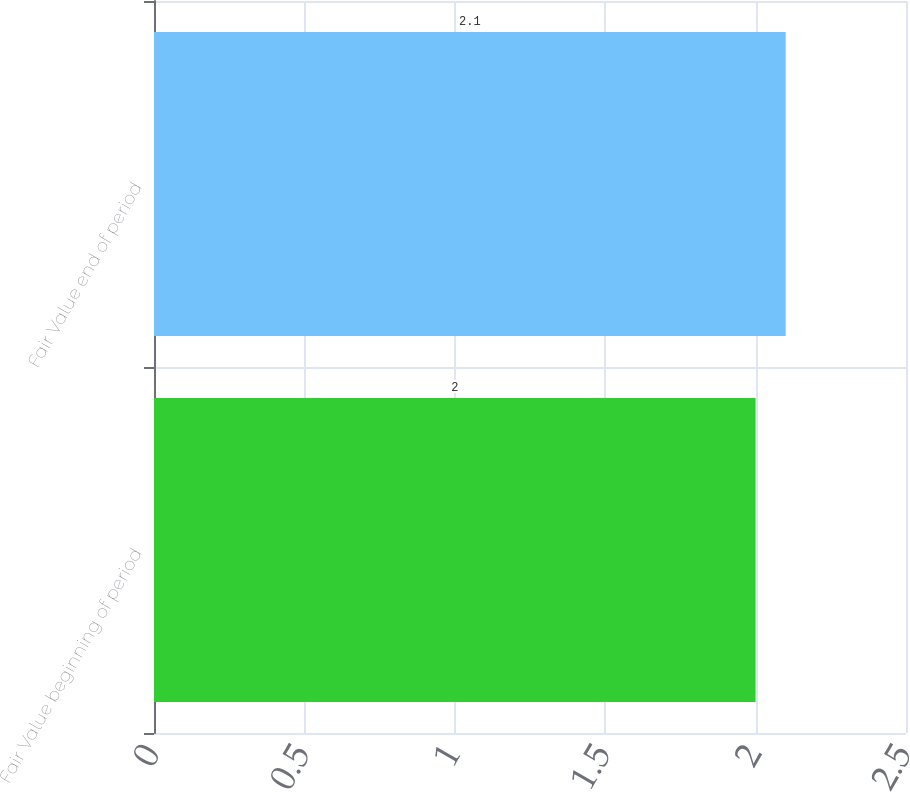Convert chart. <chart><loc_0><loc_0><loc_500><loc_500><bar_chart><fcel>Fair Value beginning of period<fcel>Fair Value end of period<nl><fcel>2<fcel>2.1<nl></chart> 